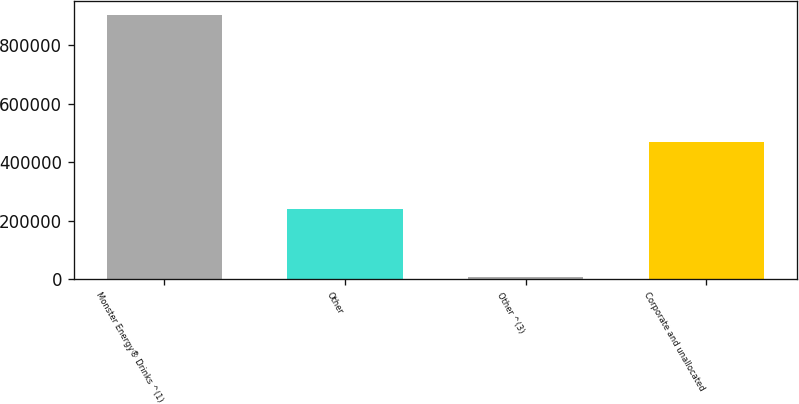Convert chart to OTSL. <chart><loc_0><loc_0><loc_500><loc_500><bar_chart><fcel>Monster Energy® Drinks ^(1)<fcel>Other<fcel>Other ^(3)<fcel>Corporate and unallocated<nl><fcel>904224<fcel>238253<fcel>7560<fcel>468946<nl></chart> 